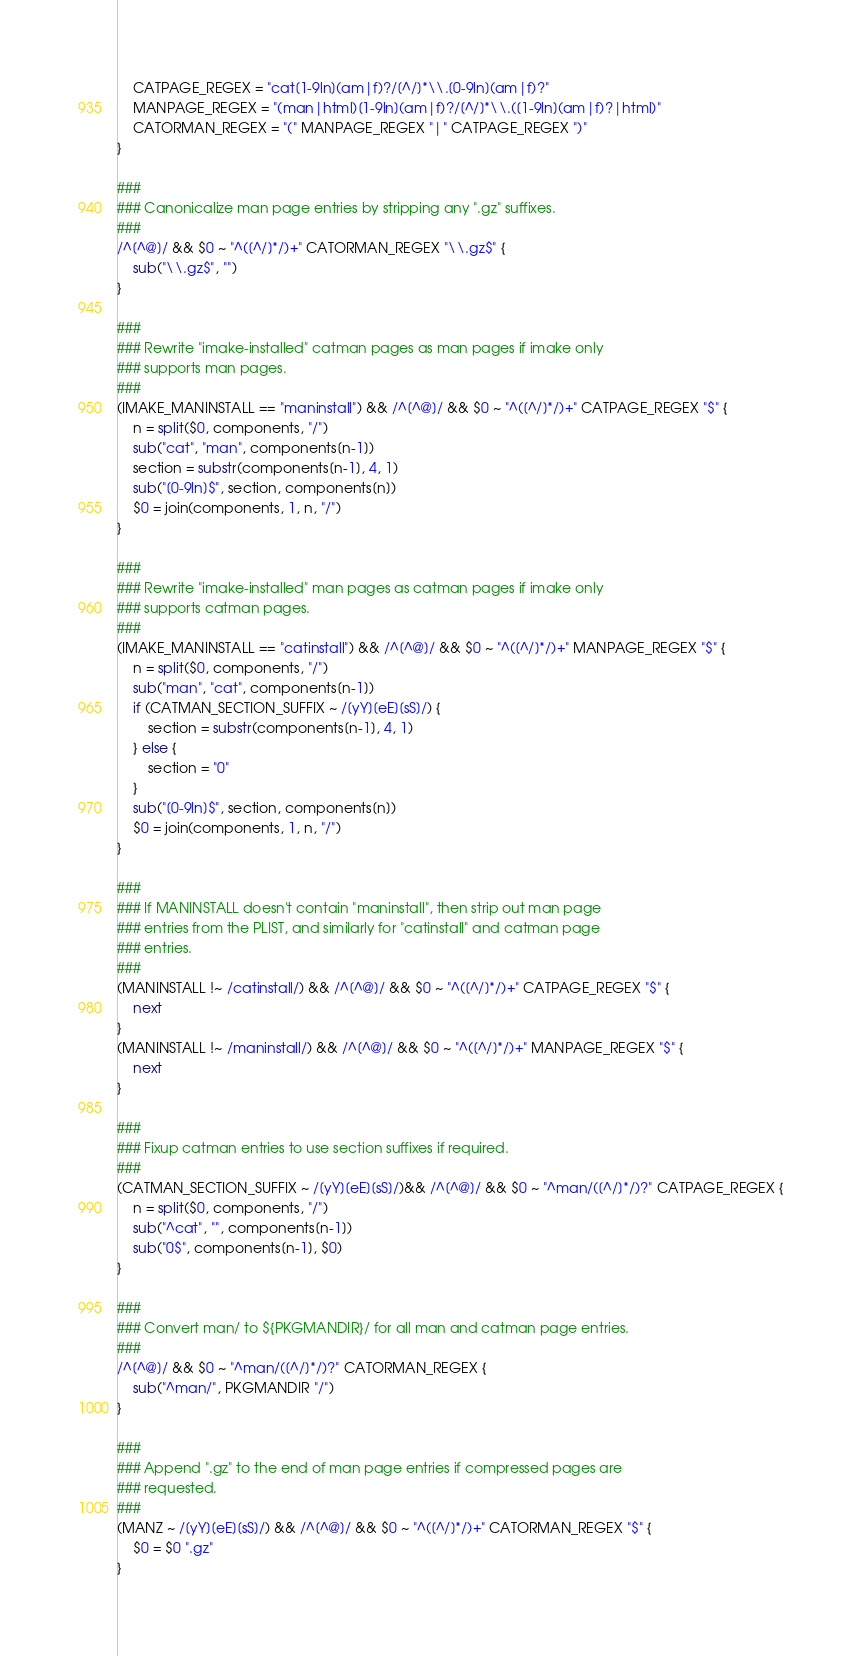<code> <loc_0><loc_0><loc_500><loc_500><_Awk_>	CATPAGE_REGEX = "cat[1-9ln](am|f)?/[^/]*\\.[0-9ln](am|f)?"
	MANPAGE_REGEX = "(man|html)[1-9ln](am|f)?/[^/]*\\.([1-9ln](am|f)?|html)"
	CATORMAN_REGEX = "(" MANPAGE_REGEX "|" CATPAGE_REGEX ")"
}

###
### Canonicalize man page entries by stripping any ".gz" suffixes.
###
/^[^@]/ && $0 ~ "^([^/]*/)+" CATORMAN_REGEX "\\.gz$" {
	sub("\\.gz$", "")
}

###
### Rewrite "imake-installed" catman pages as man pages if imake only
### supports man pages.
###
(IMAKE_MANINSTALL == "maninstall") && /^[^@]/ && $0 ~ "^([^/]*/)+" CATPAGE_REGEX "$" {
	n = split($0, components, "/")
	sub("cat", "man", components[n-1])
	section = substr(components[n-1], 4, 1)
	sub("[0-9ln]$", section, components[n])
	$0 = join(components, 1, n, "/")
}

###
### Rewrite "imake-installed" man pages as catman pages if imake only
### supports catman pages.
###
(IMAKE_MANINSTALL == "catinstall") && /^[^@]/ && $0 ~ "^([^/]*/)+" MANPAGE_REGEX "$" {
	n = split($0, components, "/")
	sub("man", "cat", components[n-1])
	if (CATMAN_SECTION_SUFFIX ~ /[yY][eE][sS]/) {
		section = substr(components[n-1], 4, 1)
	} else {
		section = "0"
	}
	sub("[0-9ln]$", section, components[n])
	$0 = join(components, 1, n, "/")
}

###
### If MANINSTALL doesn't contain "maninstall", then strip out man page
### entries from the PLIST, and similarly for "catinstall" and catman page
### entries.
###
(MANINSTALL !~ /catinstall/) && /^[^@]/ && $0 ~ "^([^/]*/)+" CATPAGE_REGEX "$" {
	next
}
(MANINSTALL !~ /maninstall/) && /^[^@]/ && $0 ~ "^([^/]*/)+" MANPAGE_REGEX "$" {
	next
}

###
### Fixup catman entries to use section suffixes if required.
###
(CATMAN_SECTION_SUFFIX ~ /[yY][eE][sS]/)&& /^[^@]/ && $0 ~ "^man/([^/]*/)?" CATPAGE_REGEX {
	n = split($0, components, "/")
	sub("^cat", "", components[n-1])
	sub("0$", components[n-1], $0)
}

###
### Convert man/ to ${PKGMANDIR}/ for all man and catman page entries.
###
/^[^@]/ && $0 ~ "^man/([^/]*/)?" CATORMAN_REGEX {
	sub("^man/", PKGMANDIR "/")
}

###
### Append ".gz" to the end of man page entries if compressed pages are
### requested.
###
(MANZ ~ /[yY][eE][sS]/) && /^[^@]/ && $0 ~ "^([^/]*/)+" CATORMAN_REGEX "$" {
	$0 = $0 ".gz"
}
</code> 